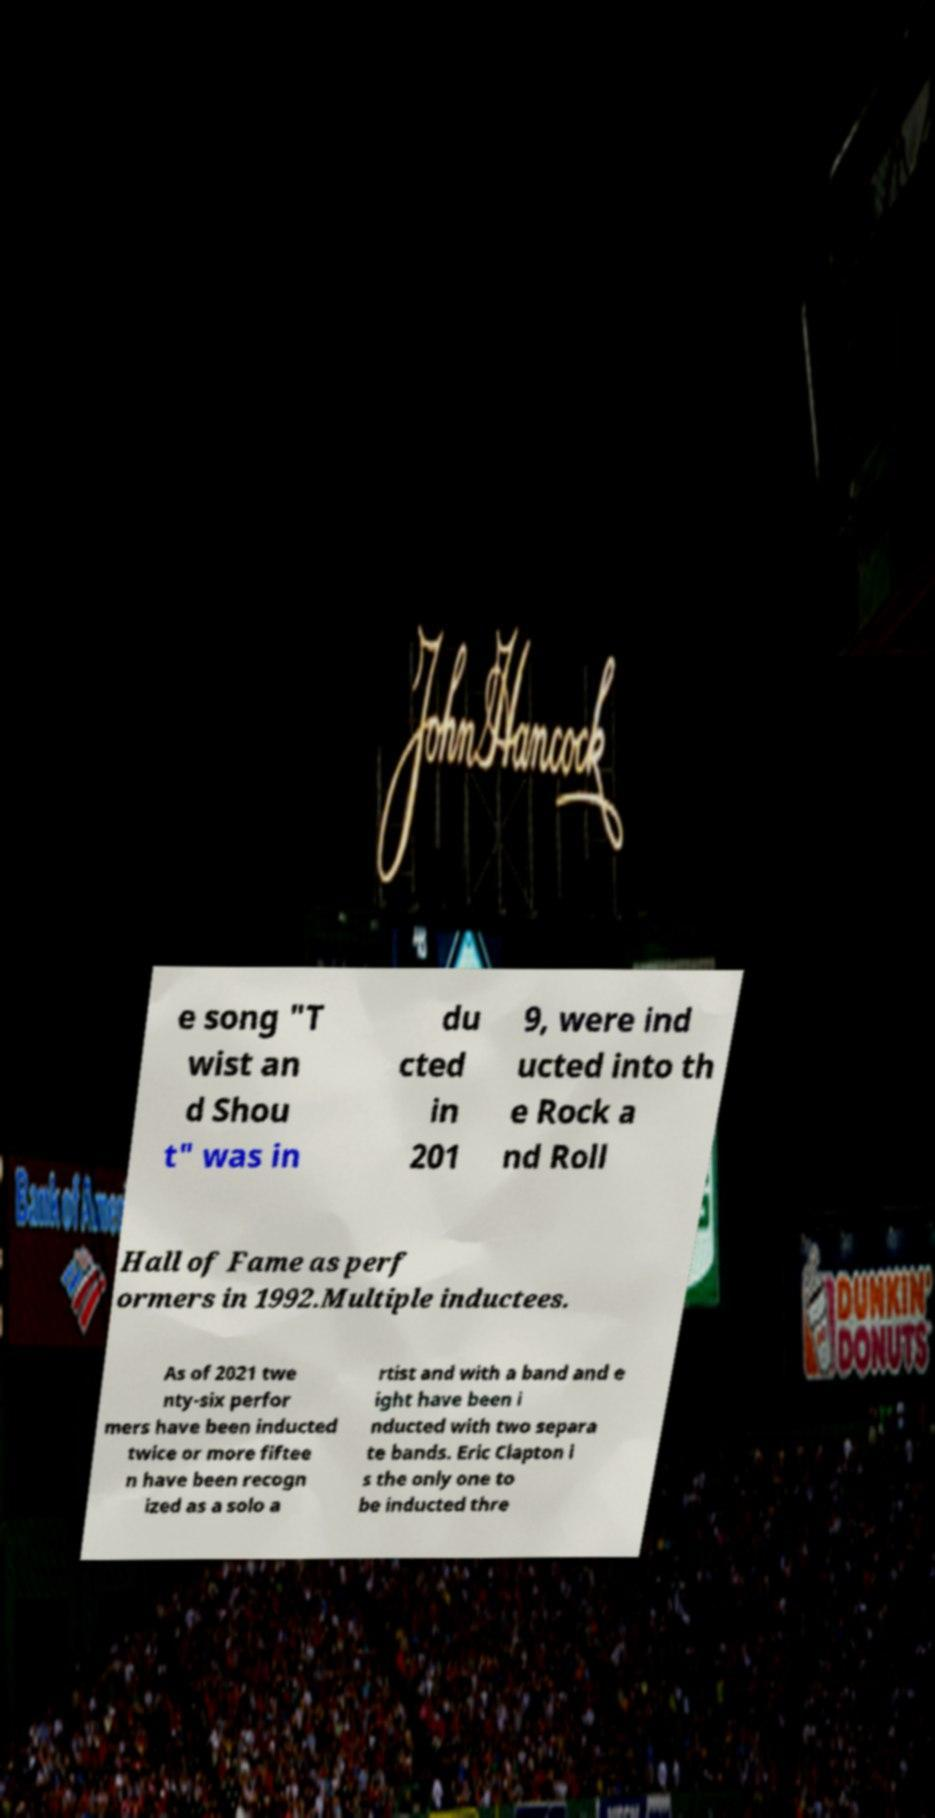There's text embedded in this image that I need extracted. Can you transcribe it verbatim? e song "T wist an d Shou t" was in du cted in 201 9, were ind ucted into th e Rock a nd Roll Hall of Fame as perf ormers in 1992.Multiple inductees. As of 2021 twe nty-six perfor mers have been inducted twice or more fiftee n have been recogn ized as a solo a rtist and with a band and e ight have been i nducted with two separa te bands. Eric Clapton i s the only one to be inducted thre 